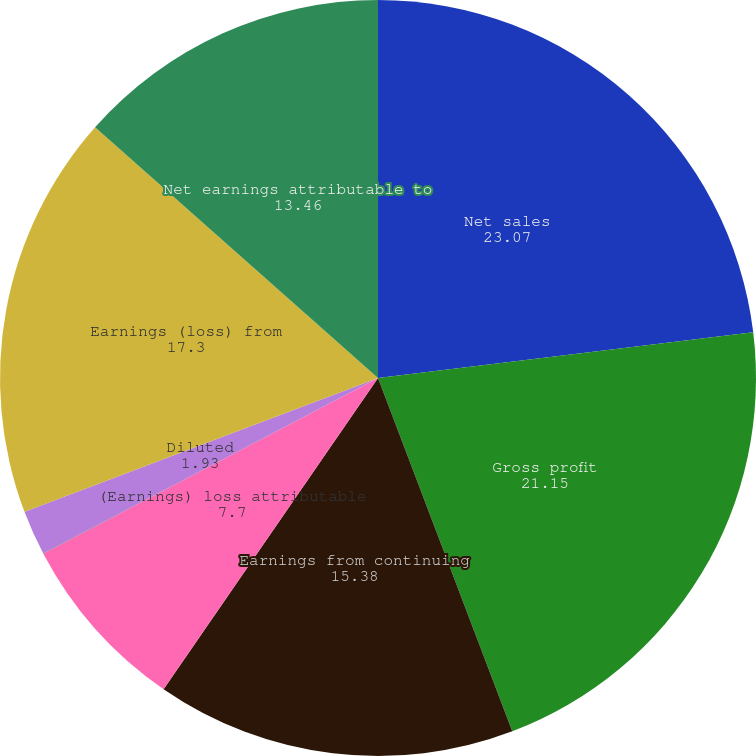Convert chart. <chart><loc_0><loc_0><loc_500><loc_500><pie_chart><fcel>Net sales<fcel>Gross profit<fcel>Earnings from continuing<fcel>(Earnings) loss attributable<fcel>Basic<fcel>Diluted<fcel>Earnings (loss) from<fcel>Net earnings attributable to<nl><fcel>23.07%<fcel>21.15%<fcel>15.38%<fcel>7.7%<fcel>0.01%<fcel>1.93%<fcel>17.3%<fcel>13.46%<nl></chart> 